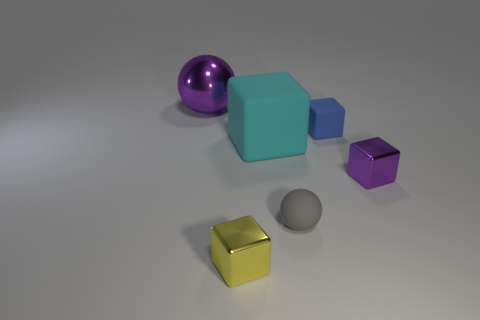How many objects are small metal blocks that are in front of the purple shiny block or tiny metallic things?
Provide a short and direct response. 2. There is a purple thing that is the same size as the yellow metal block; what is its shape?
Ensure brevity in your answer.  Cube. There is a ball left of the small gray thing; is it the same size as the metallic object that is to the right of the small gray ball?
Provide a short and direct response. No. There is another small cube that is the same material as the cyan cube; what color is it?
Offer a terse response. Blue. Do the purple object on the left side of the small blue matte cube and the purple object that is right of the metal sphere have the same material?
Offer a terse response. Yes. Is there a yellow block of the same size as the blue matte object?
Ensure brevity in your answer.  Yes. There is a purple thing on the left side of the small matte thing in front of the tiny purple object; what is its size?
Offer a terse response. Large. What number of big metallic balls have the same color as the large metallic thing?
Keep it short and to the point. 0. There is a shiny object that is behind the tiny metal thing behind the tiny gray rubber object; what shape is it?
Give a very brief answer. Sphere. How many gray balls have the same material as the yellow thing?
Offer a terse response. 0. 